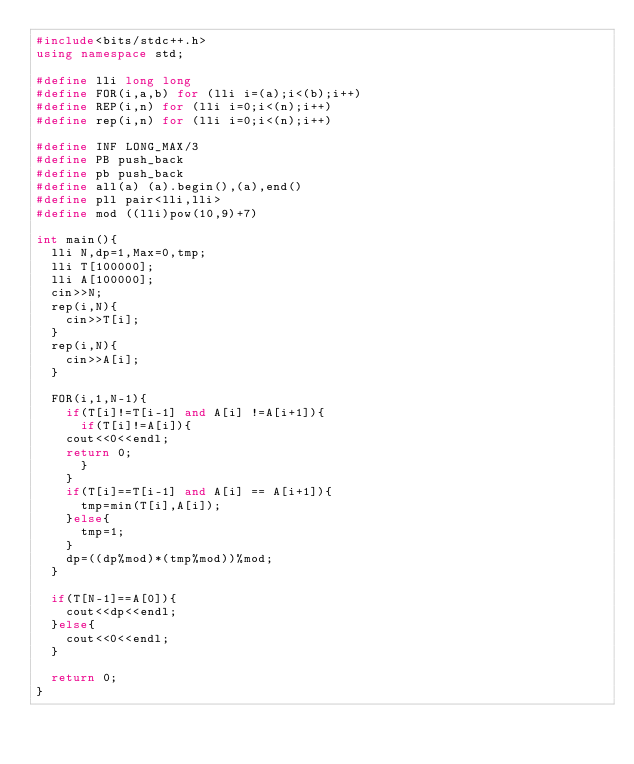<code> <loc_0><loc_0><loc_500><loc_500><_C++_>#include<bits/stdc++.h>
using namespace std;

#define lli long long
#define FOR(i,a,b) for (lli i=(a);i<(b);i++)
#define REP(i,n) for (lli i=0;i<(n);i++)
#define rep(i,n) for (lli i=0;i<(n);i++)

#define INF LONG_MAX/3
#define PB push_back
#define pb push_back
#define all(a) (a).begin(),(a),end()
#define pll pair<lli,lli>
#define mod ((lli)pow(10,9)+7)

int main(){
  lli N,dp=1,Max=0,tmp;
  lli T[100000];
  lli A[100000];
  cin>>N;
  rep(i,N){
    cin>>T[i];
  }
  rep(i,N){
    cin>>A[i];
  }

  FOR(i,1,N-1){
    if(T[i]!=T[i-1] and A[i] !=A[i+1]){
      if(T[i]!=A[i]){
	cout<<0<<endl;
	return 0;
      }
    }
    if(T[i]==T[i-1] and A[i] == A[i+1]){
      tmp=min(T[i],A[i]);
    }else{
      tmp=1;
    }
    dp=((dp%mod)*(tmp%mod))%mod;
  }

  if(T[N-1]==A[0]){
    cout<<dp<<endl;
  }else{
    cout<<0<<endl;
  }
  
  return 0;
}</code> 